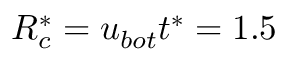<formula> <loc_0><loc_0><loc_500><loc_500>R _ { c } ^ { * } = { { u } _ { b o t } } { { t } ^ { * } } = 1 . 5</formula> 